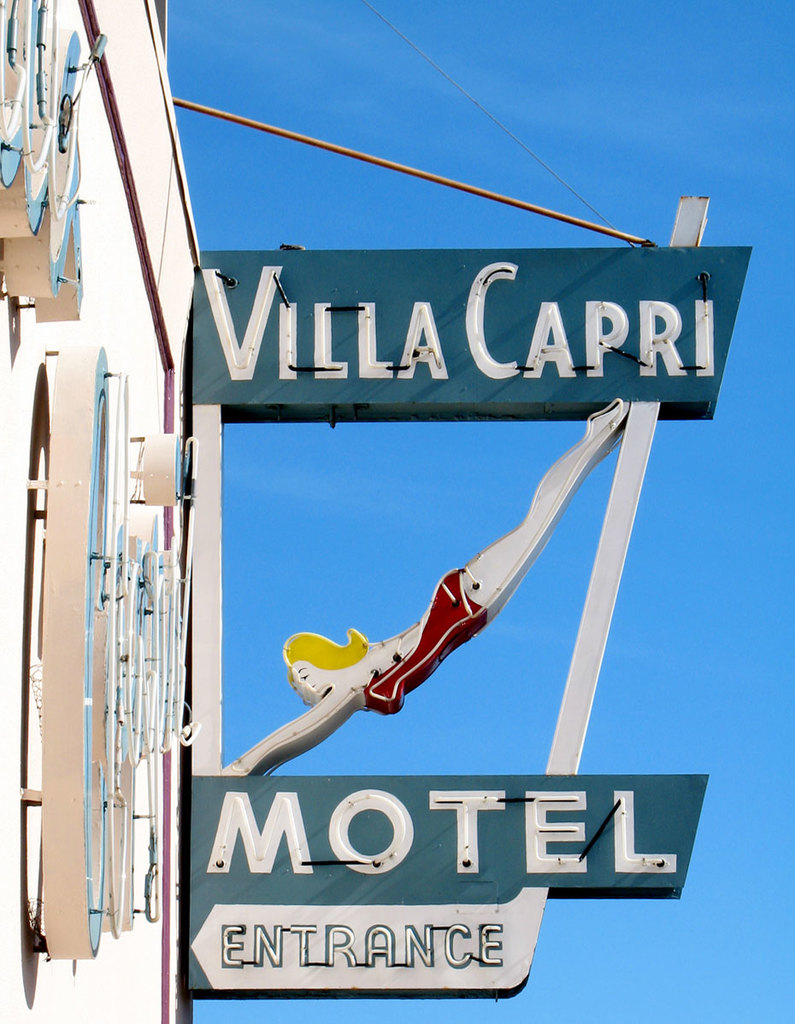Can you describe the main features of this image for me? The image features the iconic Villa Capri Motel sign, which is rich with mid-20th century Americana charm. The sign is composed of an eye-catching arrow, pointing to the right, suggesting the direction to the motel entrance. On top of the arrow sits a playful mermaid figure with blond hair and a red mermaid suit, adding a quirky touch to the sign's allure. The predominant color palette includes a retro shade of blue complementing the crisp white text and outlines, giving the sign a classic and nostalgic feel. The elegant cursive script used for 'Villa Capri' contrasts with the utilitarian block lettering of 'Motel Entrance,' creating visual interest and indicating a blend of sophistication and straightforwardness. The clear blue sky background accentuates the vintage vibe of the motel sign and adds to its visual appeal. 